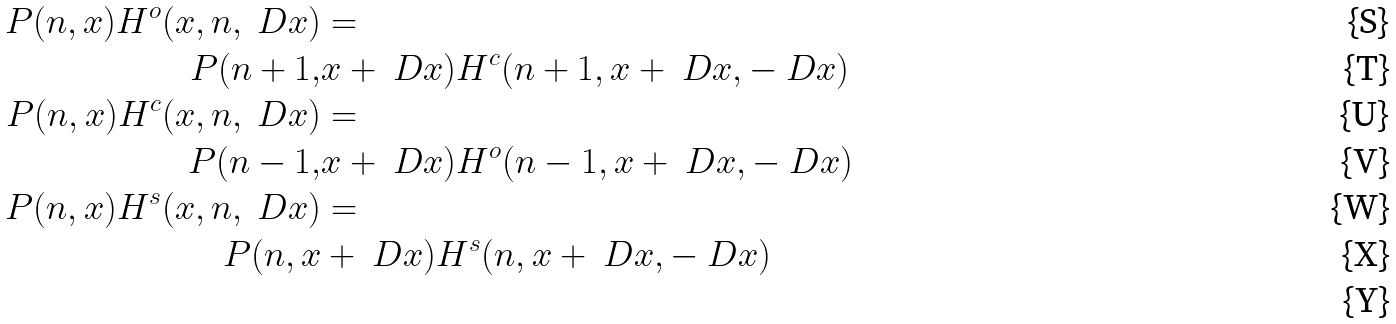<formula> <loc_0><loc_0><loc_500><loc_500>P ( n , x ) H ^ { o } ( x , n , \ D x ) & = \\ P ( n + 1 , & x + \ D x ) H ^ { c } ( n + 1 , x + \ D x , - \ D x ) \\ P ( n , x ) H ^ { c } ( x , n , \ D x ) & = \\ P ( n - 1 , & x + \ D x ) H ^ { o } ( n - 1 , x + \ D x , - \ D x ) \\ P ( n , x ) H ^ { s } ( x , n , \ D x ) & = \\ P ( n , x & + \ D x ) H ^ { s } ( n , x + \ D x , - \ D x ) \\</formula> 